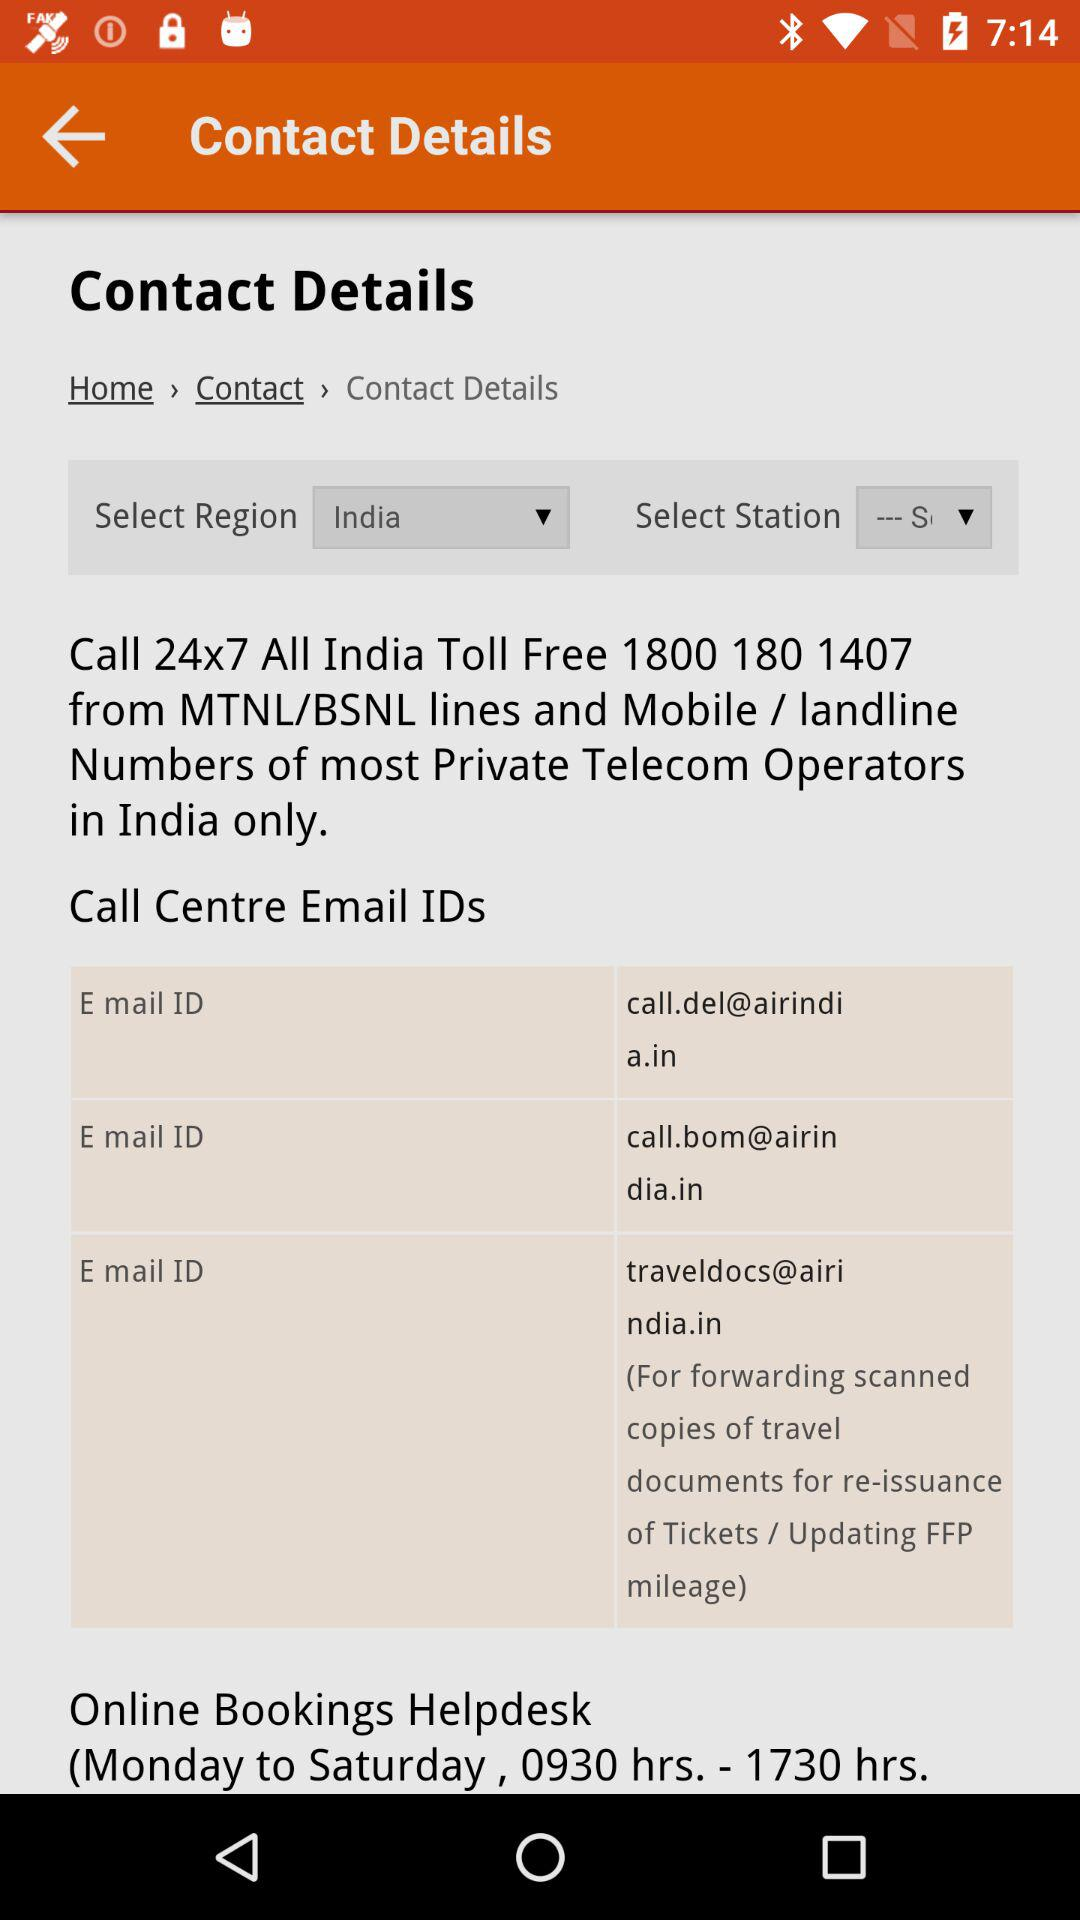Which region is selected? The selected region is India. 